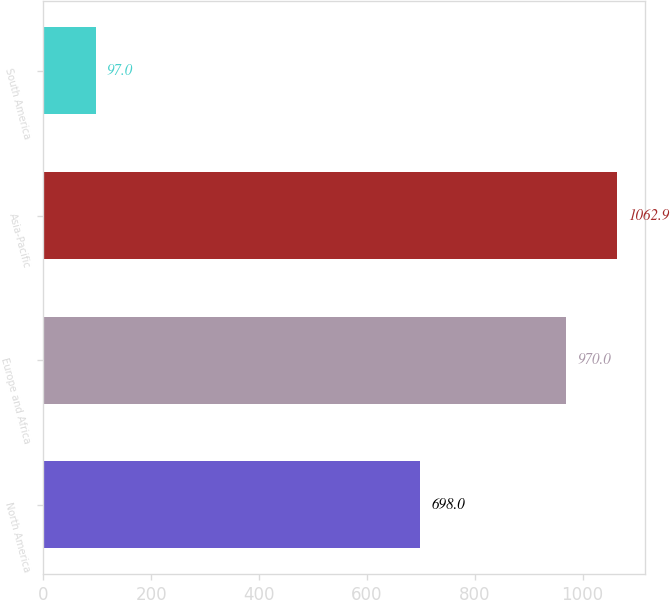Convert chart to OTSL. <chart><loc_0><loc_0><loc_500><loc_500><bar_chart><fcel>North America<fcel>Europe and Africa<fcel>Asia-Pacific<fcel>South America<nl><fcel>698<fcel>970<fcel>1062.9<fcel>97<nl></chart> 